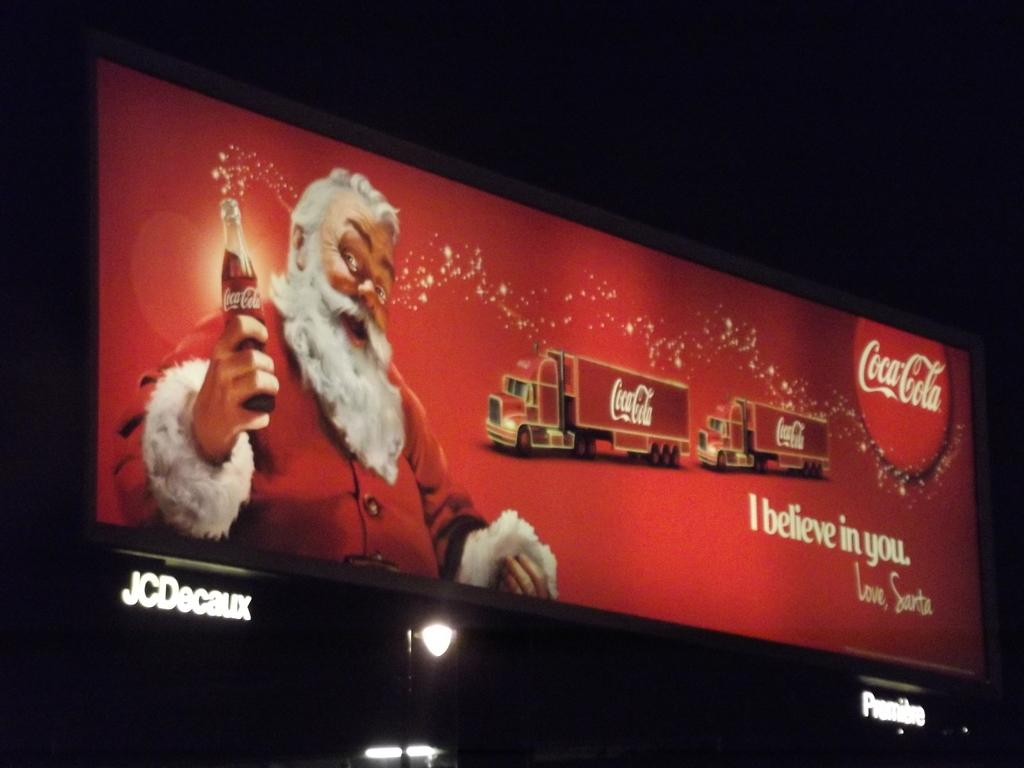Provide a one-sentence caption for the provided image. A CocaCola advertisement featuring santa holding a Coke and the phrase I believe in you. 